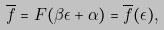<formula> <loc_0><loc_0><loc_500><loc_500>\overline { f } = F ( \beta \epsilon + \alpha ) = \overline { f } ( \epsilon ) ,</formula> 